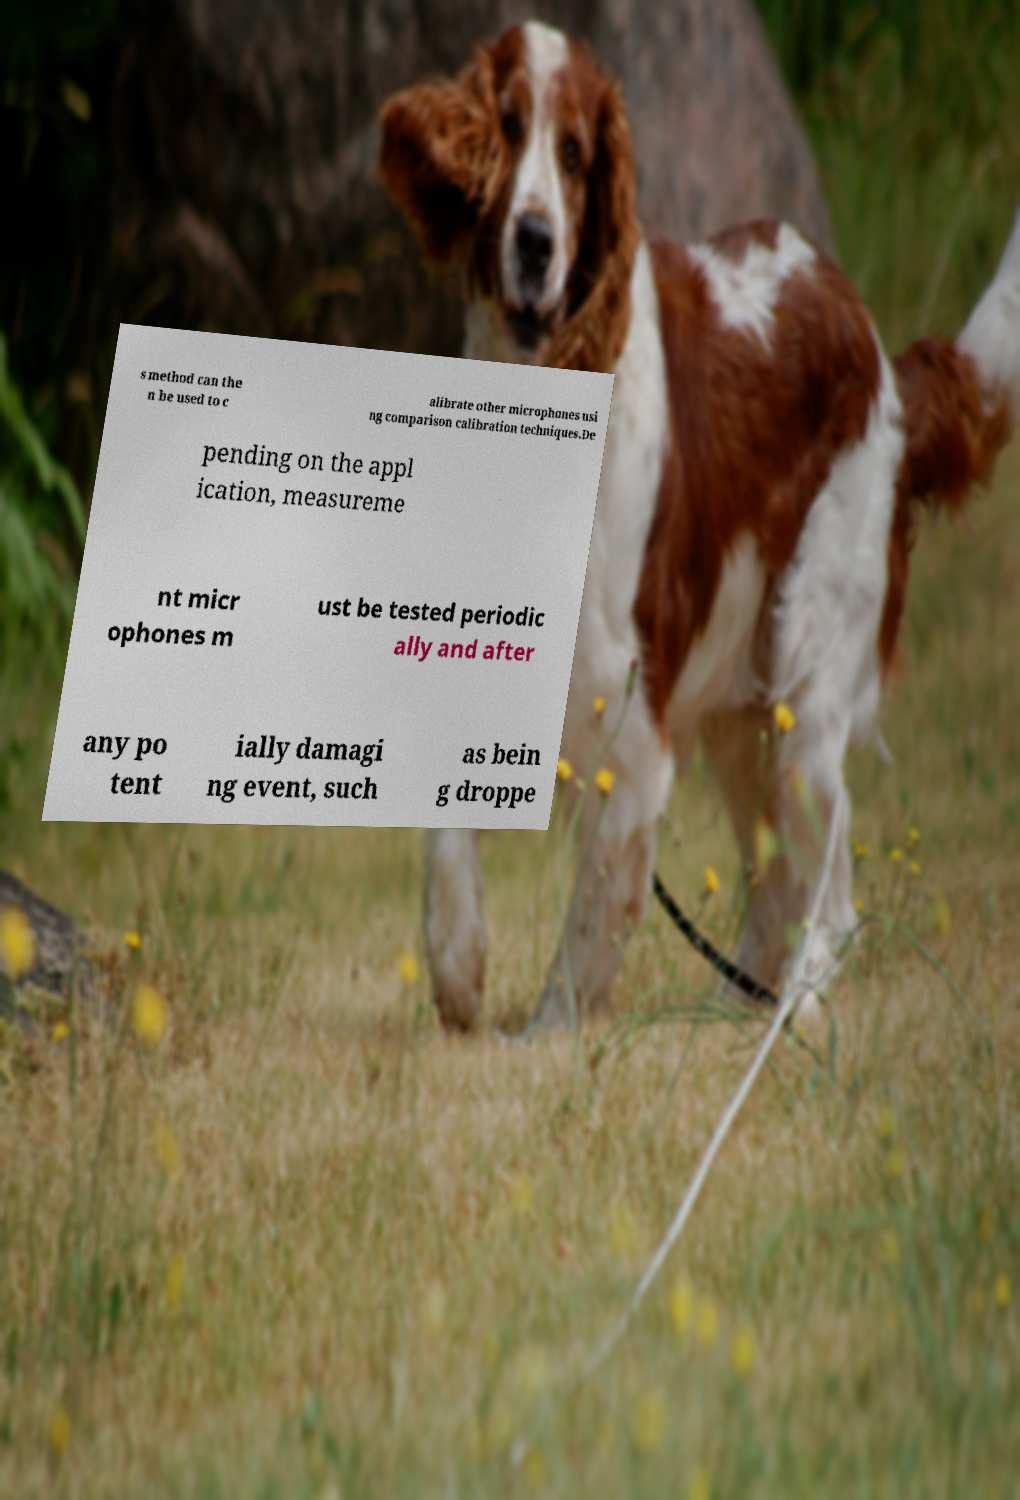There's text embedded in this image that I need extracted. Can you transcribe it verbatim? s method can the n be used to c alibrate other microphones usi ng comparison calibration techniques.De pending on the appl ication, measureme nt micr ophones m ust be tested periodic ally and after any po tent ially damagi ng event, such as bein g droppe 